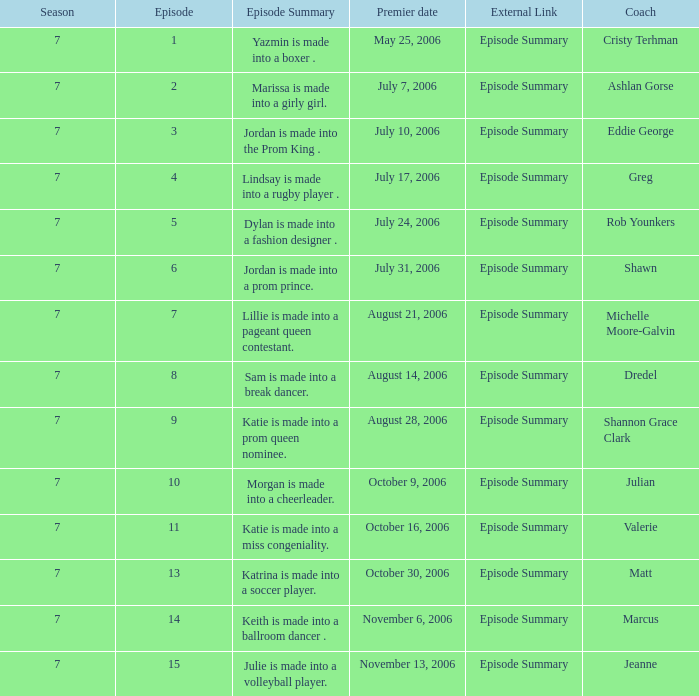What happens in episode 15's summary? Julie is made into a volleyball player. 